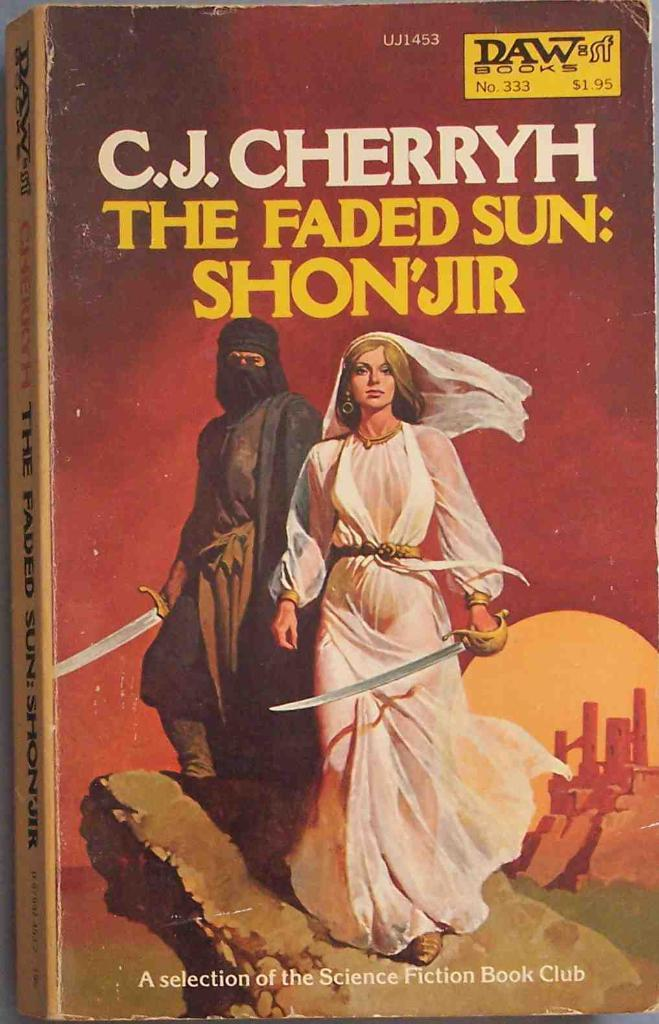What object is present in the image? There is a book in the image. What can be found inside the book? The book contains photos of two persons. Where are the persons in the photos located? The persons are standing on a rock. What else is included in the book besides the photos? There is text in the book. How is the pie distributed among the persons in the image? There is no pie present in the image; it only contains photos of two persons standing on a rock. 